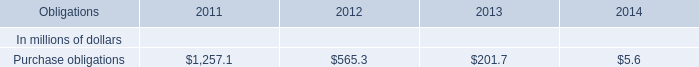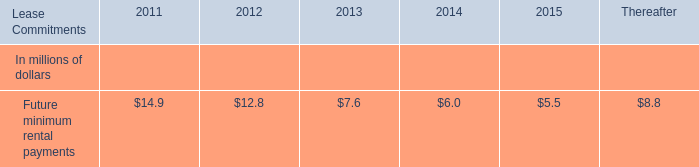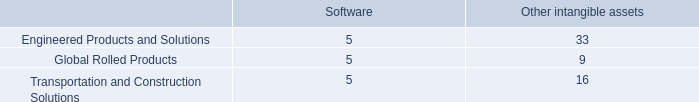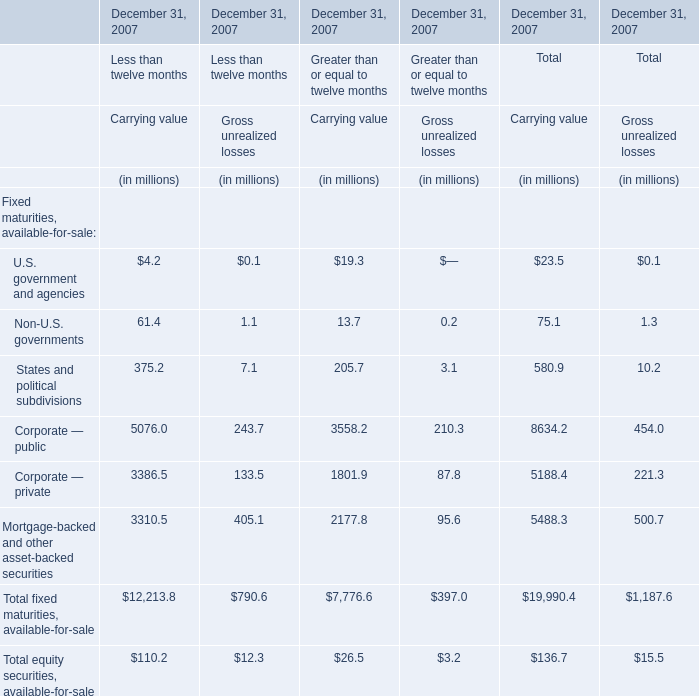What is the ratio of all elements that are smaller than 100 for Carrying value of Less than twelve months? 
Computations: ((4.2 + 61.4) / (12213.8 + 110.2))
Answer: 0.00532. 